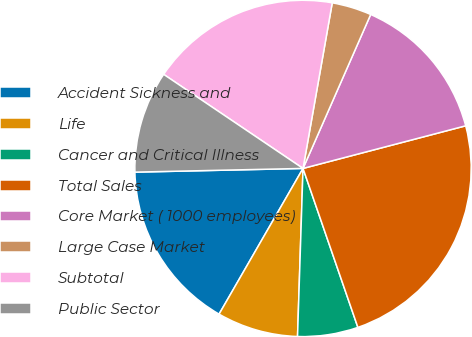Convert chart to OTSL. <chart><loc_0><loc_0><loc_500><loc_500><pie_chart><fcel>Accident Sickness and<fcel>Life<fcel>Cancer and Critical Illness<fcel>Total Sales<fcel>Core Market ( 1000 employees)<fcel>Large Case Market<fcel>Subtotal<fcel>Public Sector<nl><fcel>16.33%<fcel>7.8%<fcel>5.81%<fcel>23.79%<fcel>14.33%<fcel>3.81%<fcel>18.33%<fcel>9.8%<nl></chart> 